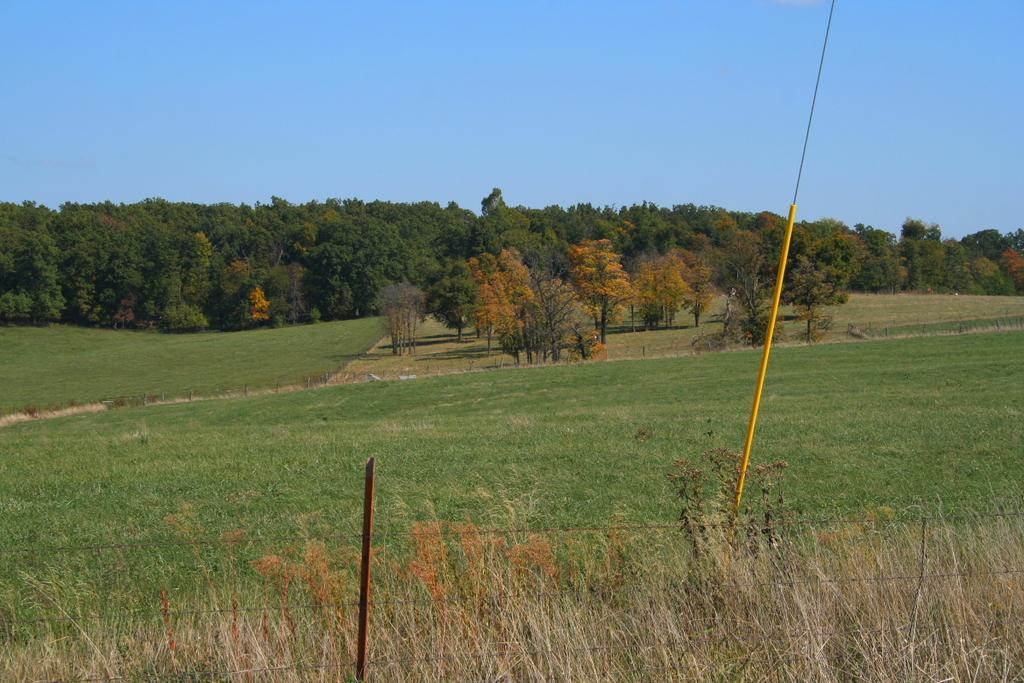What type of surface can be seen at the bottom of the image? The ground is visible in the image. What type of vegetation is present in the image? There is grass, plants, and trees in the image. What structures can be seen in the image? There are poles and a fence in the image. What part of the natural environment is visible in the image? The sky is visible in the image. Can you describe the metal breath of the trees in the image? There is no mention of metal or breath in the image; it features trees, grass, plants, poles, a fence, and the sky. 